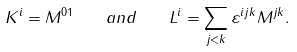<formula> <loc_0><loc_0><loc_500><loc_500>K ^ { i } = M ^ { 0 1 } \quad a n d \quad L ^ { i } = \sum _ { j < k } \varepsilon ^ { i j k } M ^ { j k } .</formula> 